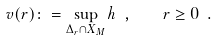<formula> <loc_0><loc_0><loc_500><loc_500>v ( r ) \colon = \sup _ { \Delta _ { r } \cap X _ { M } } h \ , \quad r \geq 0 \ .</formula> 